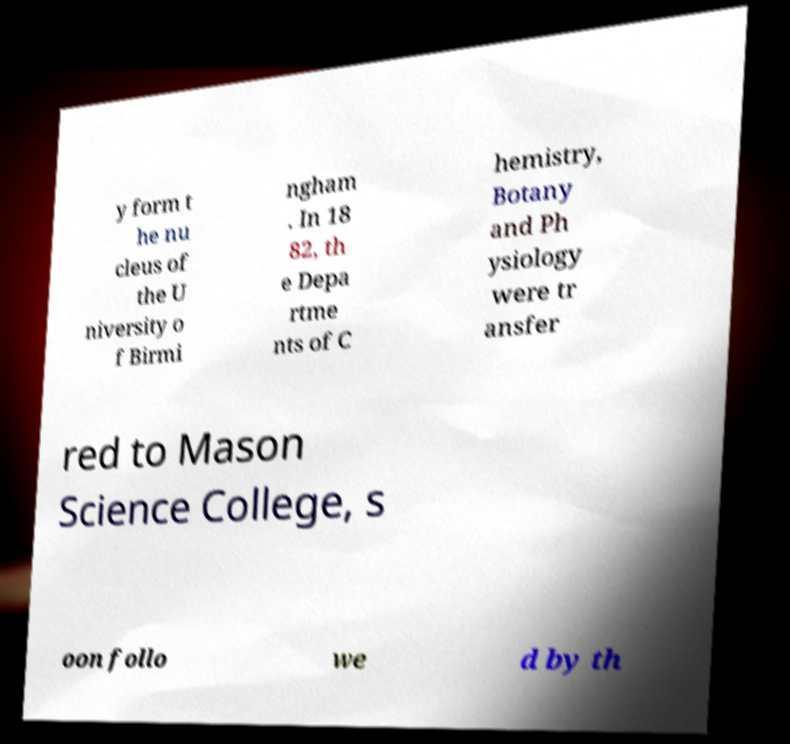Could you assist in decoding the text presented in this image and type it out clearly? y form t he nu cleus of the U niversity o f Birmi ngham . In 18 82, th e Depa rtme nts of C hemistry, Botany and Ph ysiology were tr ansfer red to Mason Science College, s oon follo we d by th 